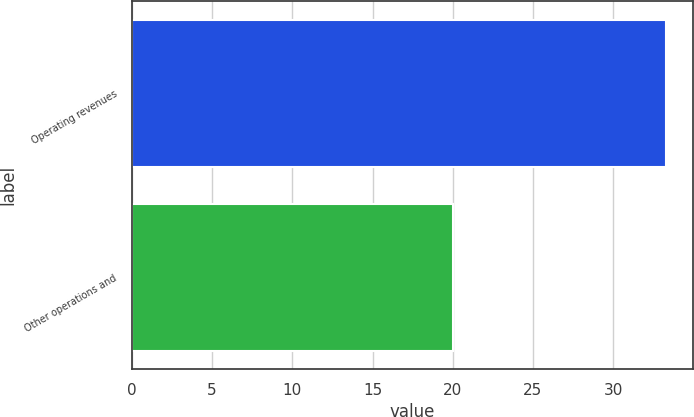Convert chart to OTSL. <chart><loc_0><loc_0><loc_500><loc_500><bar_chart><fcel>Operating revenues<fcel>Other operations and<nl><fcel>33.3<fcel>20<nl></chart> 